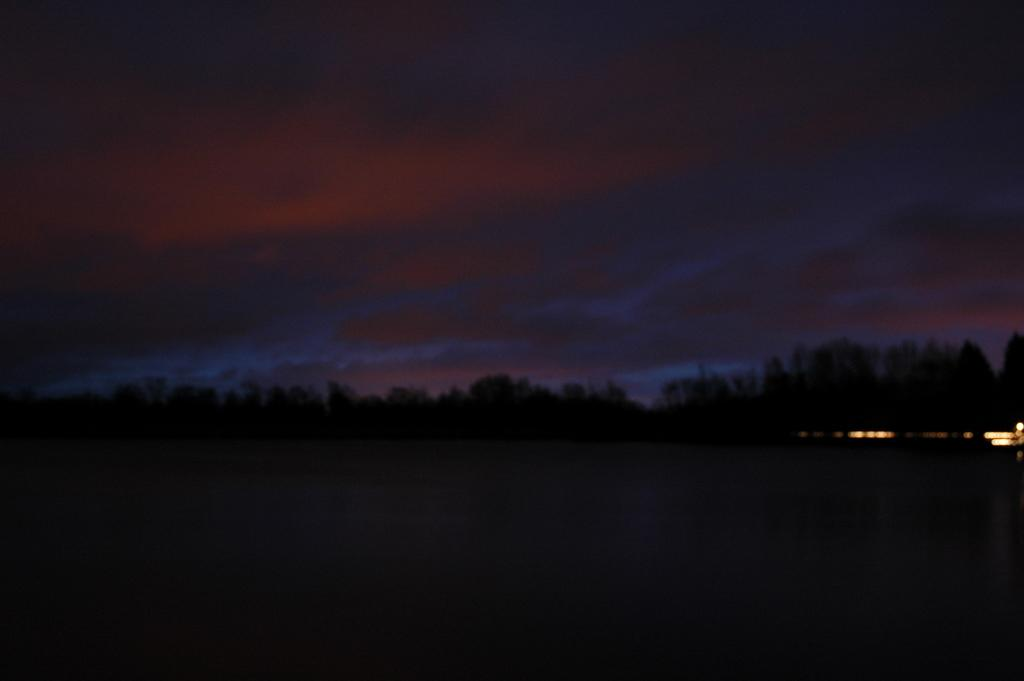What type of natural elements can be seen in the image? There are trees in the image. How would you describe the lighting conditions in the image? The lights in the image are in a dark state. Where is the drain located in the image? There is no drain present in the image. What type of playground equipment can be seen in the image? There is no playground equipment present in the image. 